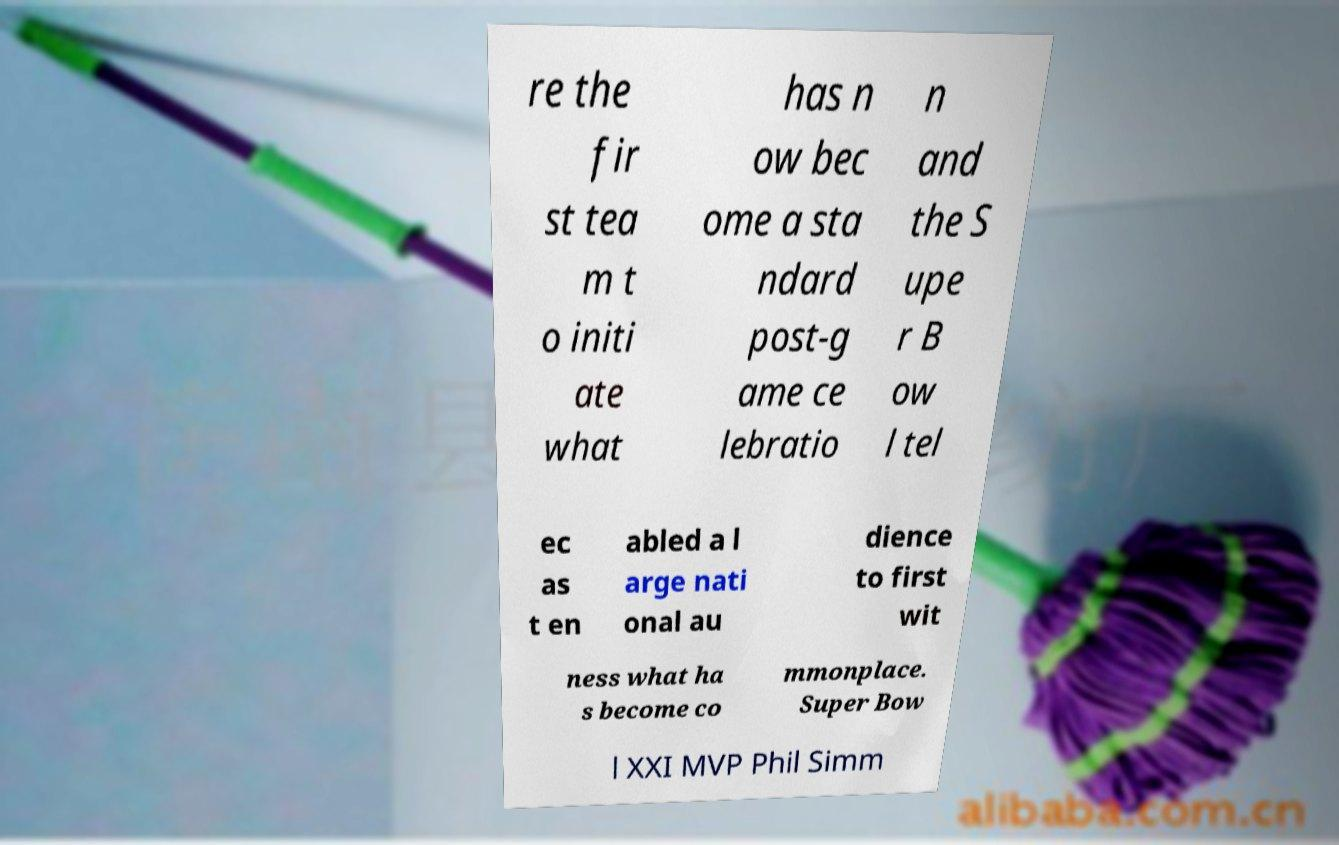Could you extract and type out the text from this image? re the fir st tea m t o initi ate what has n ow bec ome a sta ndard post-g ame ce lebratio n and the S upe r B ow l tel ec as t en abled a l arge nati onal au dience to first wit ness what ha s become co mmonplace. Super Bow l XXI MVP Phil Simm 